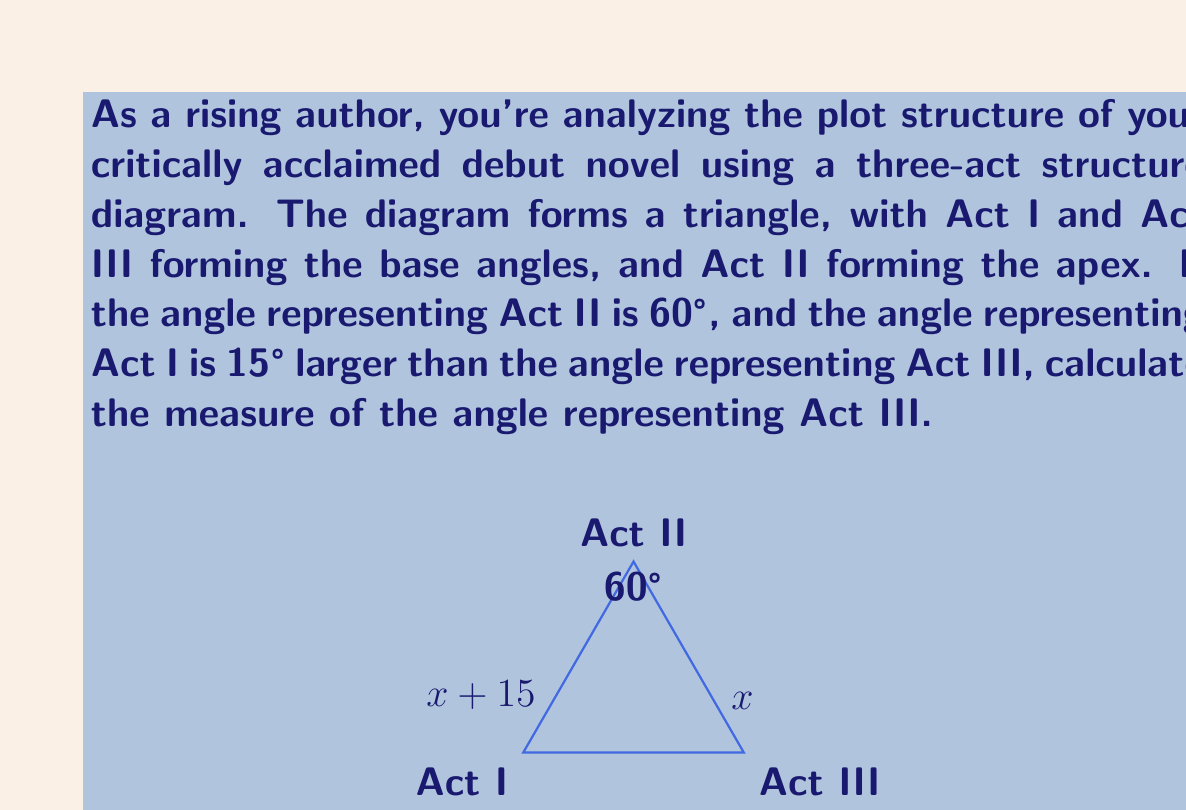Could you help me with this problem? Let's approach this step-by-step:

1) In a triangle, the sum of all interior angles is always 180°. We can express this as:

   $$(x + 15°) + 60° + x° = 180°$$

   Where $x°$ represents the measure of the Act III angle.

2) Simplify the left side of the equation:

   $$2x + 75° = 180°$$

3) Subtract 75° from both sides:

   $$2x = 105°$$

4) Divide both sides by 2:

   $$x = 52.5°$$

Therefore, the angle representing Act III is 52.5°.

We can verify:
- Act III: 52.5°
- Act I: 52.5° + 15° = 67.5°
- Act II: 60°

And indeed, $$52.5° + 67.5° + 60° = 180°$$
Answer: The measure of the angle representing Act III is 52.5°. 